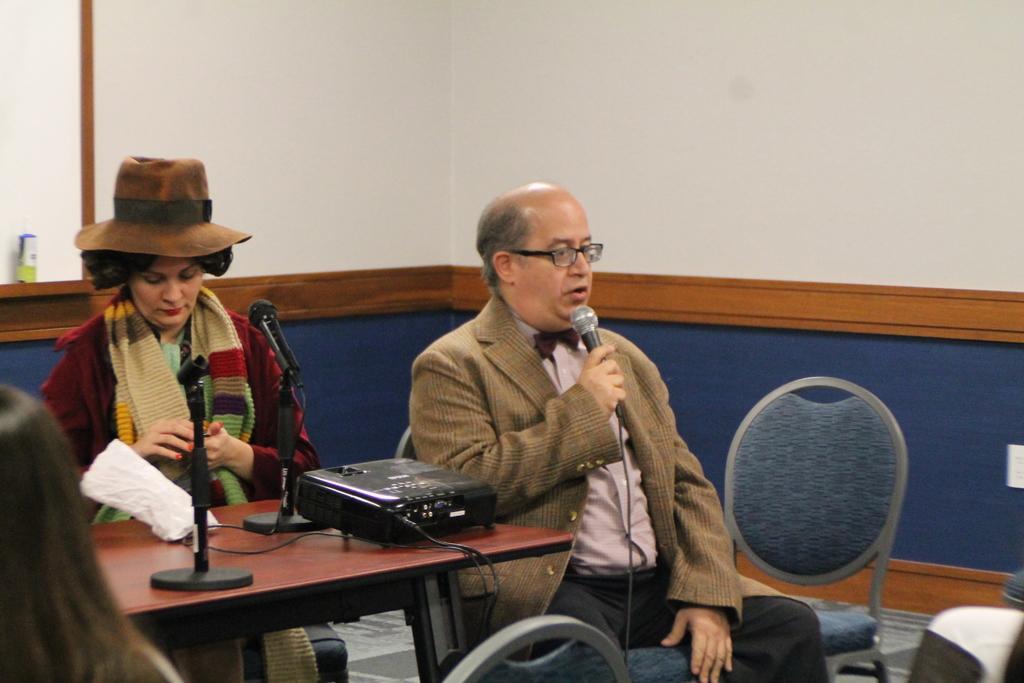Describe this image in one or two sentences. This is picture taken out side view of a room and there are the two persons sitting on the chair and on the left there is a woman wearing a red color jacket sit in front of a table on the table there is a mike and beside her a man sitting on the chair , holding a mike and wearing a spectacles and his mouth is open on the right side a chair kept on the floor. 